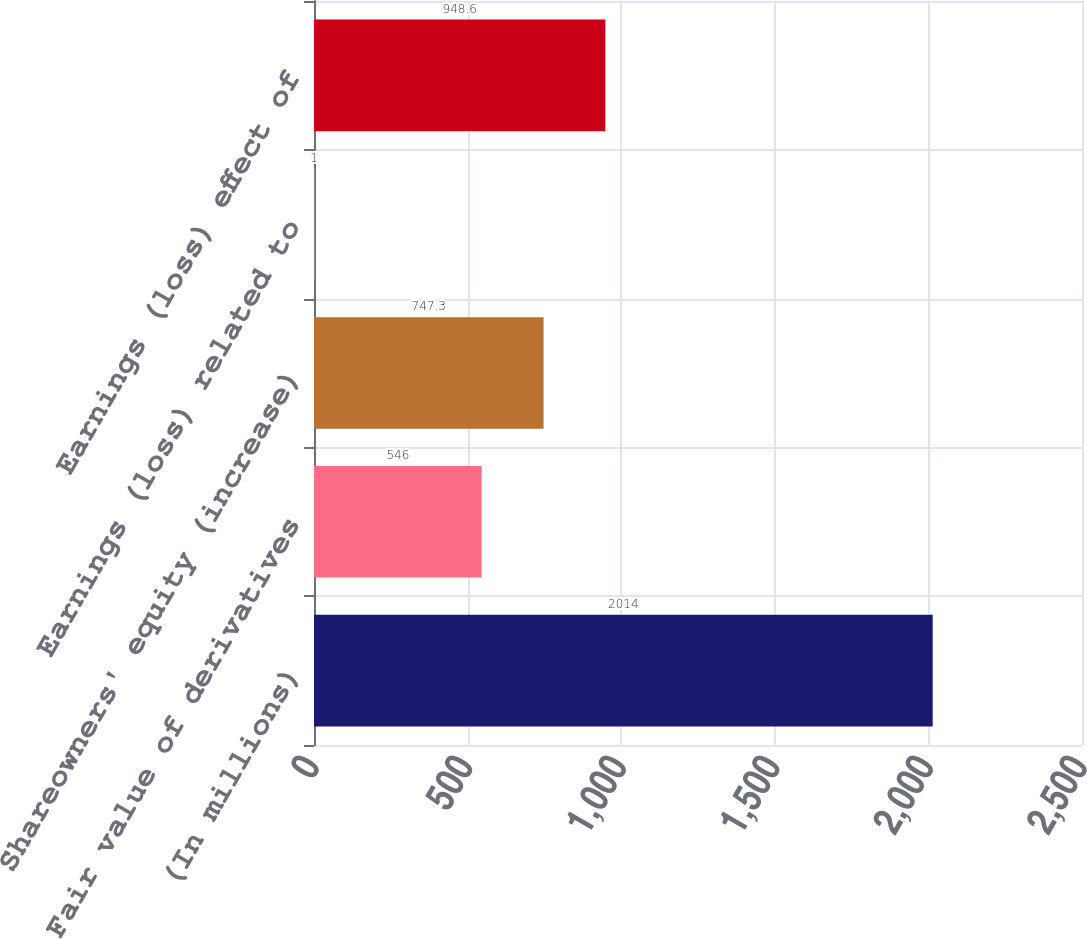Convert chart to OTSL. <chart><loc_0><loc_0><loc_500><loc_500><bar_chart><fcel>(In millions)<fcel>Fair value of derivatives<fcel>Shareowners' equity (increase)<fcel>Earnings (loss) related to<fcel>Earnings (loss) effect of<nl><fcel>2014<fcel>546<fcel>747.3<fcel>1<fcel>948.6<nl></chart> 